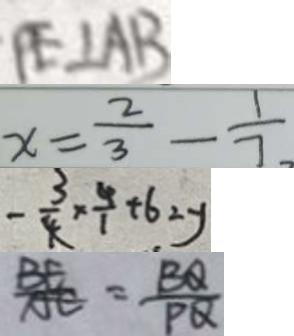Convert formula to latex. <formula><loc_0><loc_0><loc_500><loc_500>P E \bot A B 
 x = \frac { 2 } { 3 } - \frac { 1 } { 7 } 
 - \frac { 3 } { 4 } \times \frac { 4 } { 1 } + 6 2 y 
 \frac { B E } { A E } = \frac { B Q } { P Q }</formula> 